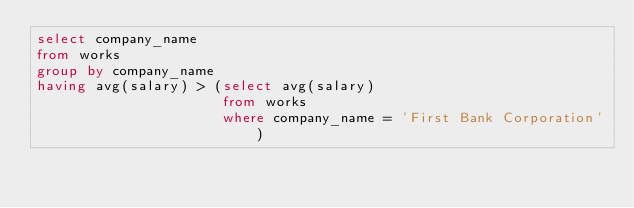<code> <loc_0><loc_0><loc_500><loc_500><_SQL_>select company_name
from works
group by company_name
having avg(salary) > (select avg(salary)
                      from works
                      where company_name = 'First Bank Corporation')</code> 